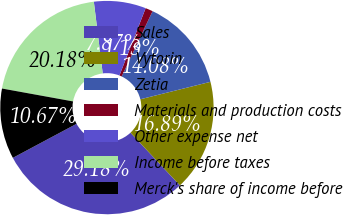Convert chart. <chart><loc_0><loc_0><loc_500><loc_500><pie_chart><fcel>Sales<fcel>Vytorin<fcel>Zetia<fcel>Materials and production costs<fcel>Other expense net<fcel>Income before taxes<fcel>Merck's share of income before<nl><fcel>29.18%<fcel>16.89%<fcel>14.08%<fcel>1.13%<fcel>7.87%<fcel>20.18%<fcel>10.67%<nl></chart> 